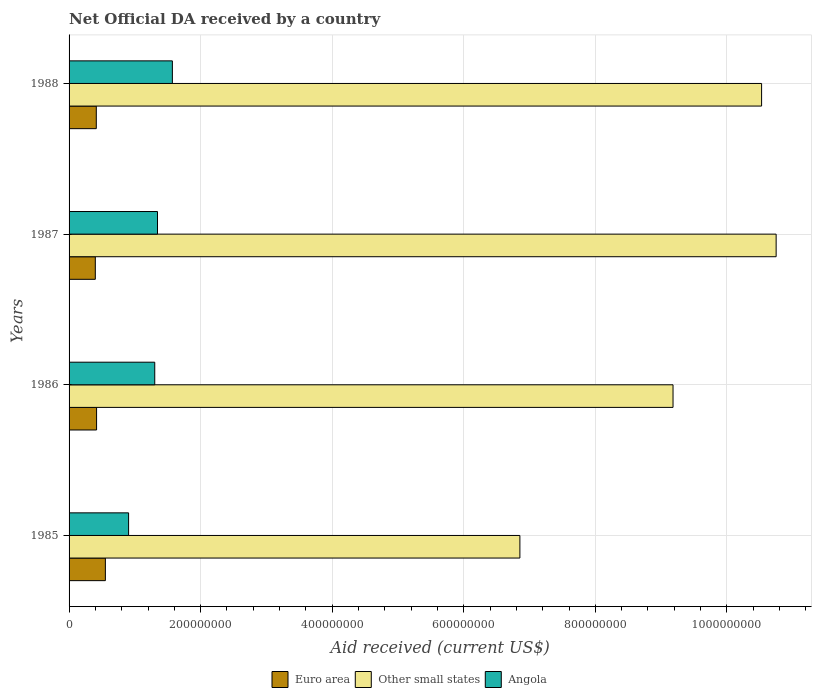Are the number of bars on each tick of the Y-axis equal?
Make the answer very short. Yes. How many bars are there on the 3rd tick from the bottom?
Provide a short and direct response. 3. In how many cases, is the number of bars for a given year not equal to the number of legend labels?
Give a very brief answer. 0. What is the net official development assistance aid received in Euro area in 1986?
Make the answer very short. 4.18e+07. Across all years, what is the maximum net official development assistance aid received in Other small states?
Provide a short and direct response. 1.07e+09. Across all years, what is the minimum net official development assistance aid received in Angola?
Give a very brief answer. 9.05e+07. In which year was the net official development assistance aid received in Angola minimum?
Your answer should be very brief. 1985. What is the total net official development assistance aid received in Other small states in the graph?
Provide a succinct answer. 3.73e+09. What is the difference between the net official development assistance aid received in Angola in 1985 and that in 1987?
Your answer should be compact. -4.39e+07. What is the difference between the net official development assistance aid received in Other small states in 1987 and the net official development assistance aid received in Euro area in 1985?
Provide a succinct answer. 1.02e+09. What is the average net official development assistance aid received in Euro area per year?
Your answer should be very brief. 4.46e+07. In the year 1987, what is the difference between the net official development assistance aid received in Other small states and net official development assistance aid received in Euro area?
Offer a terse response. 1.03e+09. In how many years, is the net official development assistance aid received in Other small states greater than 880000000 US$?
Your answer should be compact. 3. What is the ratio of the net official development assistance aid received in Euro area in 1986 to that in 1988?
Make the answer very short. 1.01. Is the net official development assistance aid received in Other small states in 1985 less than that in 1986?
Provide a short and direct response. Yes. What is the difference between the highest and the second highest net official development assistance aid received in Euro area?
Make the answer very short. 1.34e+07. What is the difference between the highest and the lowest net official development assistance aid received in Other small states?
Your response must be concise. 3.90e+08. What does the 2nd bar from the top in 1987 represents?
Make the answer very short. Other small states. What does the 1st bar from the bottom in 1985 represents?
Provide a short and direct response. Euro area. How many bars are there?
Your answer should be very brief. 12. Are all the bars in the graph horizontal?
Offer a terse response. Yes. Are the values on the major ticks of X-axis written in scientific E-notation?
Keep it short and to the point. No. Does the graph contain any zero values?
Give a very brief answer. No. Where does the legend appear in the graph?
Give a very brief answer. Bottom center. How many legend labels are there?
Offer a very short reply. 3. How are the legend labels stacked?
Give a very brief answer. Horizontal. What is the title of the graph?
Keep it short and to the point. Net Official DA received by a country. Does "East Asia (developing only)" appear as one of the legend labels in the graph?
Provide a succinct answer. No. What is the label or title of the X-axis?
Your answer should be very brief. Aid received (current US$). What is the label or title of the Y-axis?
Provide a short and direct response. Years. What is the Aid received (current US$) in Euro area in 1985?
Make the answer very short. 5.52e+07. What is the Aid received (current US$) in Other small states in 1985?
Your answer should be very brief. 6.85e+08. What is the Aid received (current US$) of Angola in 1985?
Provide a succinct answer. 9.05e+07. What is the Aid received (current US$) in Euro area in 1986?
Offer a terse response. 4.18e+07. What is the Aid received (current US$) in Other small states in 1986?
Keep it short and to the point. 9.18e+08. What is the Aid received (current US$) in Angola in 1986?
Offer a terse response. 1.30e+08. What is the Aid received (current US$) of Euro area in 1987?
Provide a succinct answer. 3.99e+07. What is the Aid received (current US$) in Other small states in 1987?
Your answer should be compact. 1.07e+09. What is the Aid received (current US$) of Angola in 1987?
Your answer should be compact. 1.34e+08. What is the Aid received (current US$) in Euro area in 1988?
Offer a terse response. 4.14e+07. What is the Aid received (current US$) of Other small states in 1988?
Your answer should be compact. 1.05e+09. What is the Aid received (current US$) of Angola in 1988?
Offer a very short reply. 1.57e+08. Across all years, what is the maximum Aid received (current US$) in Euro area?
Ensure brevity in your answer.  5.52e+07. Across all years, what is the maximum Aid received (current US$) of Other small states?
Make the answer very short. 1.07e+09. Across all years, what is the maximum Aid received (current US$) of Angola?
Keep it short and to the point. 1.57e+08. Across all years, what is the minimum Aid received (current US$) in Euro area?
Your answer should be very brief. 3.99e+07. Across all years, what is the minimum Aid received (current US$) of Other small states?
Provide a succinct answer. 6.85e+08. Across all years, what is the minimum Aid received (current US$) of Angola?
Offer a very short reply. 9.05e+07. What is the total Aid received (current US$) of Euro area in the graph?
Keep it short and to the point. 1.78e+08. What is the total Aid received (current US$) in Other small states in the graph?
Provide a short and direct response. 3.73e+09. What is the total Aid received (current US$) of Angola in the graph?
Keep it short and to the point. 5.12e+08. What is the difference between the Aid received (current US$) in Euro area in 1985 and that in 1986?
Provide a short and direct response. 1.34e+07. What is the difference between the Aid received (current US$) of Other small states in 1985 and that in 1986?
Your response must be concise. -2.33e+08. What is the difference between the Aid received (current US$) in Angola in 1985 and that in 1986?
Offer a very short reply. -3.98e+07. What is the difference between the Aid received (current US$) of Euro area in 1985 and that in 1987?
Offer a very short reply. 1.53e+07. What is the difference between the Aid received (current US$) in Other small states in 1985 and that in 1987?
Offer a very short reply. -3.90e+08. What is the difference between the Aid received (current US$) of Angola in 1985 and that in 1987?
Your answer should be very brief. -4.39e+07. What is the difference between the Aid received (current US$) of Euro area in 1985 and that in 1988?
Your response must be concise. 1.38e+07. What is the difference between the Aid received (current US$) of Other small states in 1985 and that in 1988?
Offer a terse response. -3.67e+08. What is the difference between the Aid received (current US$) in Angola in 1985 and that in 1988?
Offer a very short reply. -6.65e+07. What is the difference between the Aid received (current US$) in Euro area in 1986 and that in 1987?
Your response must be concise. 1.92e+06. What is the difference between the Aid received (current US$) in Other small states in 1986 and that in 1987?
Make the answer very short. -1.57e+08. What is the difference between the Aid received (current US$) of Angola in 1986 and that in 1987?
Ensure brevity in your answer.  -4.18e+06. What is the difference between the Aid received (current US$) of Other small states in 1986 and that in 1988?
Offer a terse response. -1.35e+08. What is the difference between the Aid received (current US$) of Angola in 1986 and that in 1988?
Give a very brief answer. -2.68e+07. What is the difference between the Aid received (current US$) of Euro area in 1987 and that in 1988?
Offer a very short reply. -1.49e+06. What is the difference between the Aid received (current US$) in Other small states in 1987 and that in 1988?
Ensure brevity in your answer.  2.21e+07. What is the difference between the Aid received (current US$) in Angola in 1987 and that in 1988?
Offer a terse response. -2.26e+07. What is the difference between the Aid received (current US$) in Euro area in 1985 and the Aid received (current US$) in Other small states in 1986?
Make the answer very short. -8.63e+08. What is the difference between the Aid received (current US$) of Euro area in 1985 and the Aid received (current US$) of Angola in 1986?
Keep it short and to the point. -7.51e+07. What is the difference between the Aid received (current US$) of Other small states in 1985 and the Aid received (current US$) of Angola in 1986?
Your response must be concise. 5.55e+08. What is the difference between the Aid received (current US$) in Euro area in 1985 and the Aid received (current US$) in Other small states in 1987?
Provide a succinct answer. -1.02e+09. What is the difference between the Aid received (current US$) in Euro area in 1985 and the Aid received (current US$) in Angola in 1987?
Ensure brevity in your answer.  -7.92e+07. What is the difference between the Aid received (current US$) in Other small states in 1985 and the Aid received (current US$) in Angola in 1987?
Keep it short and to the point. 5.51e+08. What is the difference between the Aid received (current US$) in Euro area in 1985 and the Aid received (current US$) in Other small states in 1988?
Offer a very short reply. -9.98e+08. What is the difference between the Aid received (current US$) of Euro area in 1985 and the Aid received (current US$) of Angola in 1988?
Make the answer very short. -1.02e+08. What is the difference between the Aid received (current US$) of Other small states in 1985 and the Aid received (current US$) of Angola in 1988?
Make the answer very short. 5.28e+08. What is the difference between the Aid received (current US$) of Euro area in 1986 and the Aid received (current US$) of Other small states in 1987?
Provide a succinct answer. -1.03e+09. What is the difference between the Aid received (current US$) in Euro area in 1986 and the Aid received (current US$) in Angola in 1987?
Provide a short and direct response. -9.26e+07. What is the difference between the Aid received (current US$) in Other small states in 1986 and the Aid received (current US$) in Angola in 1987?
Your response must be concise. 7.84e+08. What is the difference between the Aid received (current US$) in Euro area in 1986 and the Aid received (current US$) in Other small states in 1988?
Your response must be concise. -1.01e+09. What is the difference between the Aid received (current US$) of Euro area in 1986 and the Aid received (current US$) of Angola in 1988?
Your answer should be very brief. -1.15e+08. What is the difference between the Aid received (current US$) of Other small states in 1986 and the Aid received (current US$) of Angola in 1988?
Make the answer very short. 7.61e+08. What is the difference between the Aid received (current US$) in Euro area in 1987 and the Aid received (current US$) in Other small states in 1988?
Your answer should be compact. -1.01e+09. What is the difference between the Aid received (current US$) of Euro area in 1987 and the Aid received (current US$) of Angola in 1988?
Give a very brief answer. -1.17e+08. What is the difference between the Aid received (current US$) in Other small states in 1987 and the Aid received (current US$) in Angola in 1988?
Provide a short and direct response. 9.18e+08. What is the average Aid received (current US$) in Euro area per year?
Give a very brief answer. 4.46e+07. What is the average Aid received (current US$) of Other small states per year?
Your response must be concise. 9.33e+08. What is the average Aid received (current US$) of Angola per year?
Your answer should be very brief. 1.28e+08. In the year 1985, what is the difference between the Aid received (current US$) in Euro area and Aid received (current US$) in Other small states?
Your answer should be compact. -6.30e+08. In the year 1985, what is the difference between the Aid received (current US$) of Euro area and Aid received (current US$) of Angola?
Provide a succinct answer. -3.53e+07. In the year 1985, what is the difference between the Aid received (current US$) in Other small states and Aid received (current US$) in Angola?
Make the answer very short. 5.95e+08. In the year 1986, what is the difference between the Aid received (current US$) in Euro area and Aid received (current US$) in Other small states?
Your answer should be very brief. -8.76e+08. In the year 1986, what is the difference between the Aid received (current US$) of Euro area and Aid received (current US$) of Angola?
Make the answer very short. -8.84e+07. In the year 1986, what is the difference between the Aid received (current US$) of Other small states and Aid received (current US$) of Angola?
Offer a terse response. 7.88e+08. In the year 1987, what is the difference between the Aid received (current US$) in Euro area and Aid received (current US$) in Other small states?
Offer a terse response. -1.03e+09. In the year 1987, what is the difference between the Aid received (current US$) of Euro area and Aid received (current US$) of Angola?
Offer a very short reply. -9.45e+07. In the year 1987, what is the difference between the Aid received (current US$) of Other small states and Aid received (current US$) of Angola?
Your response must be concise. 9.40e+08. In the year 1988, what is the difference between the Aid received (current US$) of Euro area and Aid received (current US$) of Other small states?
Make the answer very short. -1.01e+09. In the year 1988, what is the difference between the Aid received (current US$) of Euro area and Aid received (current US$) of Angola?
Your answer should be compact. -1.16e+08. In the year 1988, what is the difference between the Aid received (current US$) in Other small states and Aid received (current US$) in Angola?
Keep it short and to the point. 8.96e+08. What is the ratio of the Aid received (current US$) of Euro area in 1985 to that in 1986?
Keep it short and to the point. 1.32. What is the ratio of the Aid received (current US$) in Other small states in 1985 to that in 1986?
Provide a succinct answer. 0.75. What is the ratio of the Aid received (current US$) of Angola in 1985 to that in 1986?
Offer a terse response. 0.69. What is the ratio of the Aid received (current US$) in Euro area in 1985 to that in 1987?
Provide a succinct answer. 1.38. What is the ratio of the Aid received (current US$) in Other small states in 1985 to that in 1987?
Offer a very short reply. 0.64. What is the ratio of the Aid received (current US$) of Angola in 1985 to that in 1987?
Provide a succinct answer. 0.67. What is the ratio of the Aid received (current US$) in Euro area in 1985 to that in 1988?
Give a very brief answer. 1.33. What is the ratio of the Aid received (current US$) of Other small states in 1985 to that in 1988?
Keep it short and to the point. 0.65. What is the ratio of the Aid received (current US$) in Angola in 1985 to that in 1988?
Your response must be concise. 0.58. What is the ratio of the Aid received (current US$) of Euro area in 1986 to that in 1987?
Ensure brevity in your answer.  1.05. What is the ratio of the Aid received (current US$) of Other small states in 1986 to that in 1987?
Your answer should be compact. 0.85. What is the ratio of the Aid received (current US$) of Angola in 1986 to that in 1987?
Your answer should be compact. 0.97. What is the ratio of the Aid received (current US$) in Euro area in 1986 to that in 1988?
Your answer should be very brief. 1.01. What is the ratio of the Aid received (current US$) in Other small states in 1986 to that in 1988?
Give a very brief answer. 0.87. What is the ratio of the Aid received (current US$) of Angola in 1986 to that in 1988?
Provide a succinct answer. 0.83. What is the ratio of the Aid received (current US$) of Angola in 1987 to that in 1988?
Provide a succinct answer. 0.86. What is the difference between the highest and the second highest Aid received (current US$) in Euro area?
Your answer should be very brief. 1.34e+07. What is the difference between the highest and the second highest Aid received (current US$) in Other small states?
Your answer should be very brief. 2.21e+07. What is the difference between the highest and the second highest Aid received (current US$) of Angola?
Provide a succinct answer. 2.26e+07. What is the difference between the highest and the lowest Aid received (current US$) in Euro area?
Ensure brevity in your answer.  1.53e+07. What is the difference between the highest and the lowest Aid received (current US$) in Other small states?
Offer a very short reply. 3.90e+08. What is the difference between the highest and the lowest Aid received (current US$) of Angola?
Provide a succinct answer. 6.65e+07. 